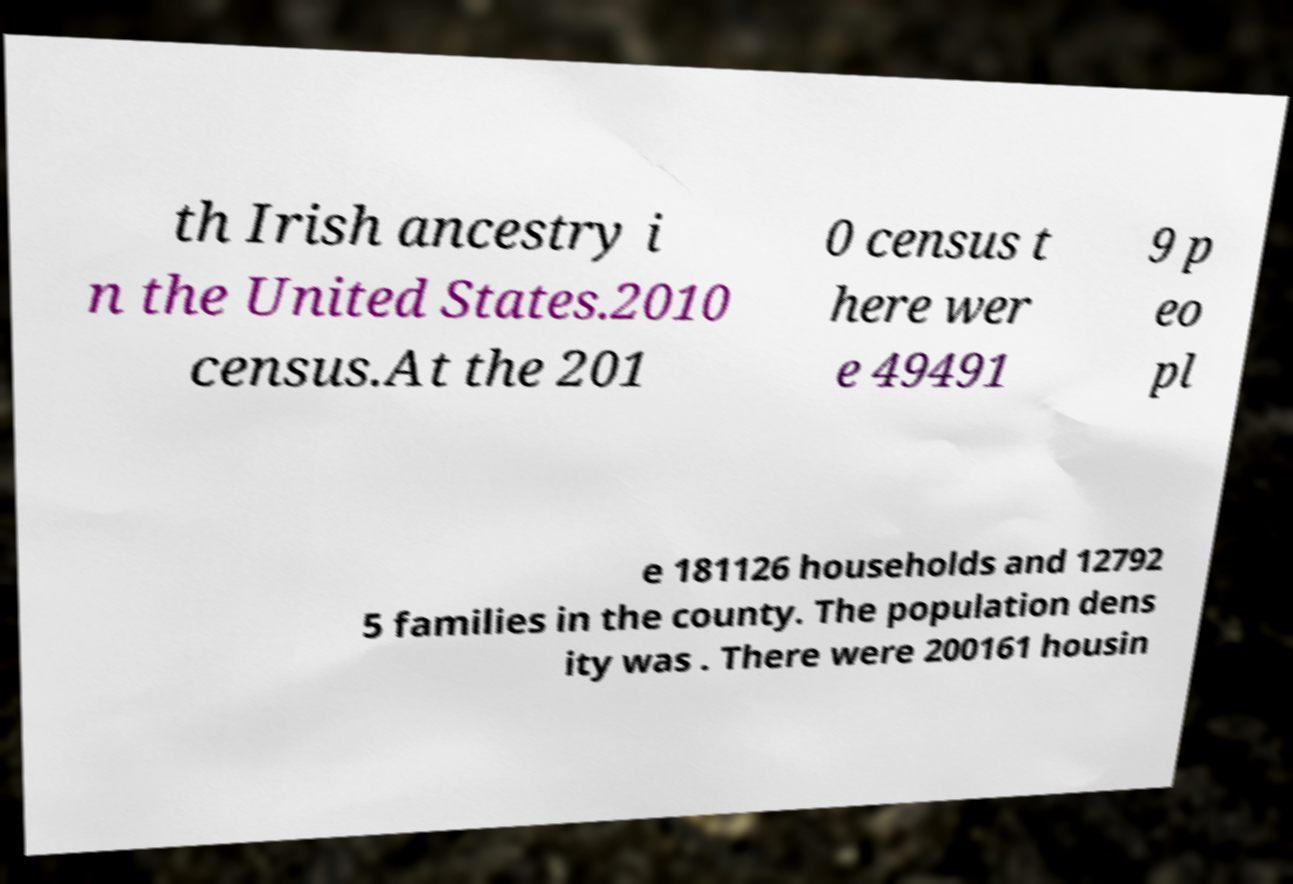Can you accurately transcribe the text from the provided image for me? th Irish ancestry i n the United States.2010 census.At the 201 0 census t here wer e 49491 9 p eo pl e 181126 households and 12792 5 families in the county. The population dens ity was . There were 200161 housin 